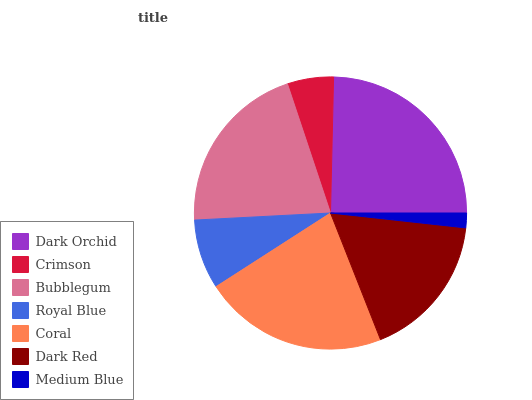Is Medium Blue the minimum?
Answer yes or no. Yes. Is Dark Orchid the maximum?
Answer yes or no. Yes. Is Crimson the minimum?
Answer yes or no. No. Is Crimson the maximum?
Answer yes or no. No. Is Dark Orchid greater than Crimson?
Answer yes or no. Yes. Is Crimson less than Dark Orchid?
Answer yes or no. Yes. Is Crimson greater than Dark Orchid?
Answer yes or no. No. Is Dark Orchid less than Crimson?
Answer yes or no. No. Is Dark Red the high median?
Answer yes or no. Yes. Is Dark Red the low median?
Answer yes or no. Yes. Is Crimson the high median?
Answer yes or no. No. Is Coral the low median?
Answer yes or no. No. 